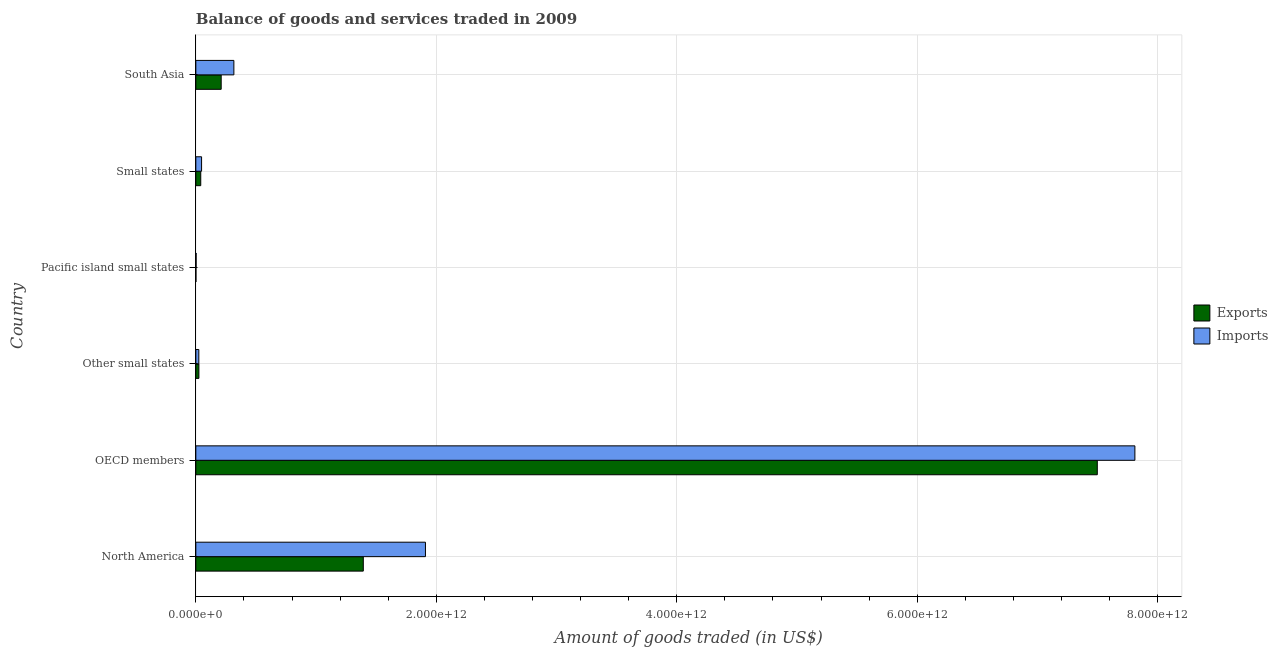How many different coloured bars are there?
Your response must be concise. 2. How many groups of bars are there?
Keep it short and to the point. 6. How many bars are there on the 4th tick from the top?
Give a very brief answer. 2. What is the label of the 4th group of bars from the top?
Your answer should be very brief. Other small states. In how many cases, is the number of bars for a given country not equal to the number of legend labels?
Ensure brevity in your answer.  0. What is the amount of goods imported in OECD members?
Your answer should be very brief. 7.81e+12. Across all countries, what is the maximum amount of goods imported?
Ensure brevity in your answer.  7.81e+12. Across all countries, what is the minimum amount of goods imported?
Provide a short and direct response. 2.46e+09. In which country was the amount of goods imported maximum?
Your response must be concise. OECD members. In which country was the amount of goods imported minimum?
Your response must be concise. Pacific island small states. What is the total amount of goods imported in the graph?
Your response must be concise. 1.01e+13. What is the difference between the amount of goods imported in North America and that in OECD members?
Make the answer very short. -5.90e+12. What is the difference between the amount of goods exported in Small states and the amount of goods imported in North America?
Your answer should be compact. -1.87e+12. What is the average amount of goods exported per country?
Your answer should be compact. 1.53e+12. What is the difference between the amount of goods imported and amount of goods exported in South Asia?
Give a very brief answer. 1.06e+11. In how many countries, is the amount of goods imported greater than 1200000000000 US$?
Provide a short and direct response. 2. What is the ratio of the amount of goods exported in North America to that in Other small states?
Your response must be concise. 54.39. Is the amount of goods imported in Pacific island small states less than that in Small states?
Provide a short and direct response. Yes. What is the difference between the highest and the second highest amount of goods imported?
Your answer should be compact. 5.90e+12. What is the difference between the highest and the lowest amount of goods imported?
Make the answer very short. 7.81e+12. In how many countries, is the amount of goods exported greater than the average amount of goods exported taken over all countries?
Offer a very short reply. 1. Is the sum of the amount of goods exported in North America and South Asia greater than the maximum amount of goods imported across all countries?
Provide a short and direct response. No. What does the 2nd bar from the top in Small states represents?
Provide a short and direct response. Exports. What does the 2nd bar from the bottom in South Asia represents?
Offer a very short reply. Imports. How many bars are there?
Ensure brevity in your answer.  12. What is the difference between two consecutive major ticks on the X-axis?
Your answer should be very brief. 2.00e+12. Are the values on the major ticks of X-axis written in scientific E-notation?
Give a very brief answer. Yes. Does the graph contain any zero values?
Provide a succinct answer. No. Where does the legend appear in the graph?
Provide a succinct answer. Center right. How many legend labels are there?
Your response must be concise. 2. How are the legend labels stacked?
Your answer should be compact. Vertical. What is the title of the graph?
Offer a very short reply. Balance of goods and services traded in 2009. Does "Primary school" appear as one of the legend labels in the graph?
Provide a short and direct response. No. What is the label or title of the X-axis?
Offer a terse response. Amount of goods traded (in US$). What is the label or title of the Y-axis?
Ensure brevity in your answer.  Country. What is the Amount of goods traded (in US$) of Exports in North America?
Ensure brevity in your answer.  1.39e+12. What is the Amount of goods traded (in US$) of Imports in North America?
Your response must be concise. 1.91e+12. What is the Amount of goods traded (in US$) of Exports in OECD members?
Your answer should be very brief. 7.50e+12. What is the Amount of goods traded (in US$) of Imports in OECD members?
Offer a terse response. 7.81e+12. What is the Amount of goods traded (in US$) in Exports in Other small states?
Your answer should be very brief. 2.56e+1. What is the Amount of goods traded (in US$) in Imports in Other small states?
Provide a succinct answer. 2.50e+1. What is the Amount of goods traded (in US$) of Exports in Pacific island small states?
Your response must be concise. 9.17e+08. What is the Amount of goods traded (in US$) in Imports in Pacific island small states?
Ensure brevity in your answer.  2.46e+09. What is the Amount of goods traded (in US$) in Exports in Small states?
Your answer should be compact. 4.10e+1. What is the Amount of goods traded (in US$) in Imports in Small states?
Make the answer very short. 4.78e+1. What is the Amount of goods traded (in US$) of Exports in South Asia?
Make the answer very short. 2.11e+11. What is the Amount of goods traded (in US$) in Imports in South Asia?
Your answer should be very brief. 3.16e+11. Across all countries, what is the maximum Amount of goods traded (in US$) of Exports?
Your response must be concise. 7.50e+12. Across all countries, what is the maximum Amount of goods traded (in US$) of Imports?
Ensure brevity in your answer.  7.81e+12. Across all countries, what is the minimum Amount of goods traded (in US$) of Exports?
Keep it short and to the point. 9.17e+08. Across all countries, what is the minimum Amount of goods traded (in US$) of Imports?
Give a very brief answer. 2.46e+09. What is the total Amount of goods traded (in US$) in Exports in the graph?
Keep it short and to the point. 9.17e+12. What is the total Amount of goods traded (in US$) of Imports in the graph?
Provide a short and direct response. 1.01e+13. What is the difference between the Amount of goods traded (in US$) of Exports in North America and that in OECD members?
Your answer should be compact. -6.11e+12. What is the difference between the Amount of goods traded (in US$) in Imports in North America and that in OECD members?
Keep it short and to the point. -5.90e+12. What is the difference between the Amount of goods traded (in US$) of Exports in North America and that in Other small states?
Your response must be concise. 1.37e+12. What is the difference between the Amount of goods traded (in US$) in Imports in North America and that in Other small states?
Offer a very short reply. 1.88e+12. What is the difference between the Amount of goods traded (in US$) in Exports in North America and that in Pacific island small states?
Your response must be concise. 1.39e+12. What is the difference between the Amount of goods traded (in US$) of Imports in North America and that in Pacific island small states?
Provide a short and direct response. 1.91e+12. What is the difference between the Amount of goods traded (in US$) in Exports in North America and that in Small states?
Provide a short and direct response. 1.35e+12. What is the difference between the Amount of goods traded (in US$) in Imports in North America and that in Small states?
Give a very brief answer. 1.86e+12. What is the difference between the Amount of goods traded (in US$) in Exports in North America and that in South Asia?
Offer a very short reply. 1.18e+12. What is the difference between the Amount of goods traded (in US$) in Imports in North America and that in South Asia?
Provide a short and direct response. 1.59e+12. What is the difference between the Amount of goods traded (in US$) in Exports in OECD members and that in Other small states?
Offer a very short reply. 7.47e+12. What is the difference between the Amount of goods traded (in US$) in Imports in OECD members and that in Other small states?
Your response must be concise. 7.79e+12. What is the difference between the Amount of goods traded (in US$) in Exports in OECD members and that in Pacific island small states?
Offer a very short reply. 7.50e+12. What is the difference between the Amount of goods traded (in US$) of Imports in OECD members and that in Pacific island small states?
Provide a succinct answer. 7.81e+12. What is the difference between the Amount of goods traded (in US$) of Exports in OECD members and that in Small states?
Provide a succinct answer. 7.46e+12. What is the difference between the Amount of goods traded (in US$) in Imports in OECD members and that in Small states?
Offer a terse response. 7.76e+12. What is the difference between the Amount of goods traded (in US$) of Exports in OECD members and that in South Asia?
Provide a succinct answer. 7.29e+12. What is the difference between the Amount of goods traded (in US$) of Imports in OECD members and that in South Asia?
Make the answer very short. 7.49e+12. What is the difference between the Amount of goods traded (in US$) of Exports in Other small states and that in Pacific island small states?
Your answer should be compact. 2.47e+1. What is the difference between the Amount of goods traded (in US$) of Imports in Other small states and that in Pacific island small states?
Your response must be concise. 2.25e+1. What is the difference between the Amount of goods traded (in US$) in Exports in Other small states and that in Small states?
Provide a short and direct response. -1.54e+1. What is the difference between the Amount of goods traded (in US$) of Imports in Other small states and that in Small states?
Offer a terse response. -2.28e+1. What is the difference between the Amount of goods traded (in US$) of Exports in Other small states and that in South Asia?
Your answer should be very brief. -1.85e+11. What is the difference between the Amount of goods traded (in US$) of Imports in Other small states and that in South Asia?
Your answer should be very brief. -2.92e+11. What is the difference between the Amount of goods traded (in US$) of Exports in Pacific island small states and that in Small states?
Make the answer very short. -4.01e+1. What is the difference between the Amount of goods traded (in US$) in Imports in Pacific island small states and that in Small states?
Provide a succinct answer. -4.53e+1. What is the difference between the Amount of goods traded (in US$) in Exports in Pacific island small states and that in South Asia?
Your response must be concise. -2.10e+11. What is the difference between the Amount of goods traded (in US$) of Imports in Pacific island small states and that in South Asia?
Offer a terse response. -3.14e+11. What is the difference between the Amount of goods traded (in US$) of Exports in Small states and that in South Asia?
Keep it short and to the point. -1.70e+11. What is the difference between the Amount of goods traded (in US$) of Imports in Small states and that in South Asia?
Your answer should be very brief. -2.69e+11. What is the difference between the Amount of goods traded (in US$) of Exports in North America and the Amount of goods traded (in US$) of Imports in OECD members?
Provide a succinct answer. -6.42e+12. What is the difference between the Amount of goods traded (in US$) in Exports in North America and the Amount of goods traded (in US$) in Imports in Other small states?
Your response must be concise. 1.37e+12. What is the difference between the Amount of goods traded (in US$) of Exports in North America and the Amount of goods traded (in US$) of Imports in Pacific island small states?
Provide a short and direct response. 1.39e+12. What is the difference between the Amount of goods traded (in US$) of Exports in North America and the Amount of goods traded (in US$) of Imports in Small states?
Offer a very short reply. 1.35e+12. What is the difference between the Amount of goods traded (in US$) in Exports in North America and the Amount of goods traded (in US$) in Imports in South Asia?
Provide a succinct answer. 1.08e+12. What is the difference between the Amount of goods traded (in US$) in Exports in OECD members and the Amount of goods traded (in US$) in Imports in Other small states?
Your answer should be compact. 7.47e+12. What is the difference between the Amount of goods traded (in US$) in Exports in OECD members and the Amount of goods traded (in US$) in Imports in Pacific island small states?
Provide a short and direct response. 7.50e+12. What is the difference between the Amount of goods traded (in US$) in Exports in OECD members and the Amount of goods traded (in US$) in Imports in Small states?
Keep it short and to the point. 7.45e+12. What is the difference between the Amount of goods traded (in US$) of Exports in OECD members and the Amount of goods traded (in US$) of Imports in South Asia?
Your answer should be compact. 7.18e+12. What is the difference between the Amount of goods traded (in US$) in Exports in Other small states and the Amount of goods traded (in US$) in Imports in Pacific island small states?
Your answer should be compact. 2.31e+1. What is the difference between the Amount of goods traded (in US$) of Exports in Other small states and the Amount of goods traded (in US$) of Imports in Small states?
Offer a very short reply. -2.22e+1. What is the difference between the Amount of goods traded (in US$) in Exports in Other small states and the Amount of goods traded (in US$) in Imports in South Asia?
Ensure brevity in your answer.  -2.91e+11. What is the difference between the Amount of goods traded (in US$) in Exports in Pacific island small states and the Amount of goods traded (in US$) in Imports in Small states?
Keep it short and to the point. -4.69e+1. What is the difference between the Amount of goods traded (in US$) in Exports in Pacific island small states and the Amount of goods traded (in US$) in Imports in South Asia?
Give a very brief answer. -3.16e+11. What is the difference between the Amount of goods traded (in US$) in Exports in Small states and the Amount of goods traded (in US$) in Imports in South Asia?
Your answer should be compact. -2.76e+11. What is the average Amount of goods traded (in US$) of Exports per country?
Offer a very short reply. 1.53e+12. What is the average Amount of goods traded (in US$) of Imports per country?
Offer a terse response. 1.69e+12. What is the difference between the Amount of goods traded (in US$) of Exports and Amount of goods traded (in US$) of Imports in North America?
Your answer should be very brief. -5.17e+11. What is the difference between the Amount of goods traded (in US$) of Exports and Amount of goods traded (in US$) of Imports in OECD members?
Give a very brief answer. -3.13e+11. What is the difference between the Amount of goods traded (in US$) of Exports and Amount of goods traded (in US$) of Imports in Other small states?
Provide a short and direct response. 6.19e+08. What is the difference between the Amount of goods traded (in US$) in Exports and Amount of goods traded (in US$) in Imports in Pacific island small states?
Provide a short and direct response. -1.55e+09. What is the difference between the Amount of goods traded (in US$) in Exports and Amount of goods traded (in US$) in Imports in Small states?
Offer a terse response. -6.78e+09. What is the difference between the Amount of goods traded (in US$) of Exports and Amount of goods traded (in US$) of Imports in South Asia?
Your answer should be compact. -1.06e+11. What is the ratio of the Amount of goods traded (in US$) of Exports in North America to that in OECD members?
Your response must be concise. 0.19. What is the ratio of the Amount of goods traded (in US$) of Imports in North America to that in OECD members?
Ensure brevity in your answer.  0.24. What is the ratio of the Amount of goods traded (in US$) of Exports in North America to that in Other small states?
Offer a terse response. 54.39. What is the ratio of the Amount of goods traded (in US$) of Imports in North America to that in Other small states?
Your response must be concise. 76.42. What is the ratio of the Amount of goods traded (in US$) in Exports in North America to that in Pacific island small states?
Give a very brief answer. 1519.43. What is the ratio of the Amount of goods traded (in US$) of Imports in North America to that in Pacific island small states?
Make the answer very short. 774.98. What is the ratio of the Amount of goods traded (in US$) of Exports in North America to that in Small states?
Provide a succinct answer. 33.98. What is the ratio of the Amount of goods traded (in US$) in Imports in North America to that in Small states?
Make the answer very short. 39.98. What is the ratio of the Amount of goods traded (in US$) in Exports in North America to that in South Asia?
Provide a short and direct response. 6.6. What is the ratio of the Amount of goods traded (in US$) in Imports in North America to that in South Asia?
Offer a very short reply. 6.03. What is the ratio of the Amount of goods traded (in US$) in Exports in OECD members to that in Other small states?
Keep it short and to the point. 292.77. What is the ratio of the Amount of goods traded (in US$) of Imports in OECD members to that in Other small states?
Your answer should be compact. 312.53. What is the ratio of the Amount of goods traded (in US$) in Exports in OECD members to that in Pacific island small states?
Your answer should be compact. 8178.65. What is the ratio of the Amount of goods traded (in US$) in Imports in OECD members to that in Pacific island small states?
Offer a terse response. 3169.43. What is the ratio of the Amount of goods traded (in US$) of Exports in OECD members to that in Small states?
Provide a short and direct response. 182.92. What is the ratio of the Amount of goods traded (in US$) in Imports in OECD members to that in Small states?
Keep it short and to the point. 163.51. What is the ratio of the Amount of goods traded (in US$) of Exports in OECD members to that in South Asia?
Your answer should be compact. 35.55. What is the ratio of the Amount of goods traded (in US$) in Imports in OECD members to that in South Asia?
Offer a very short reply. 24.68. What is the ratio of the Amount of goods traded (in US$) of Exports in Other small states to that in Pacific island small states?
Provide a short and direct response. 27.94. What is the ratio of the Amount of goods traded (in US$) in Imports in Other small states to that in Pacific island small states?
Offer a terse response. 10.14. What is the ratio of the Amount of goods traded (in US$) of Exports in Other small states to that in Small states?
Offer a terse response. 0.62. What is the ratio of the Amount of goods traded (in US$) in Imports in Other small states to that in Small states?
Provide a succinct answer. 0.52. What is the ratio of the Amount of goods traded (in US$) of Exports in Other small states to that in South Asia?
Offer a very short reply. 0.12. What is the ratio of the Amount of goods traded (in US$) of Imports in Other small states to that in South Asia?
Make the answer very short. 0.08. What is the ratio of the Amount of goods traded (in US$) of Exports in Pacific island small states to that in Small states?
Your response must be concise. 0.02. What is the ratio of the Amount of goods traded (in US$) in Imports in Pacific island small states to that in Small states?
Your answer should be very brief. 0.05. What is the ratio of the Amount of goods traded (in US$) of Exports in Pacific island small states to that in South Asia?
Offer a terse response. 0. What is the ratio of the Amount of goods traded (in US$) of Imports in Pacific island small states to that in South Asia?
Provide a succinct answer. 0.01. What is the ratio of the Amount of goods traded (in US$) in Exports in Small states to that in South Asia?
Ensure brevity in your answer.  0.19. What is the ratio of the Amount of goods traded (in US$) of Imports in Small states to that in South Asia?
Offer a terse response. 0.15. What is the difference between the highest and the second highest Amount of goods traded (in US$) in Exports?
Your answer should be compact. 6.11e+12. What is the difference between the highest and the second highest Amount of goods traded (in US$) in Imports?
Offer a very short reply. 5.90e+12. What is the difference between the highest and the lowest Amount of goods traded (in US$) of Exports?
Give a very brief answer. 7.50e+12. What is the difference between the highest and the lowest Amount of goods traded (in US$) in Imports?
Keep it short and to the point. 7.81e+12. 